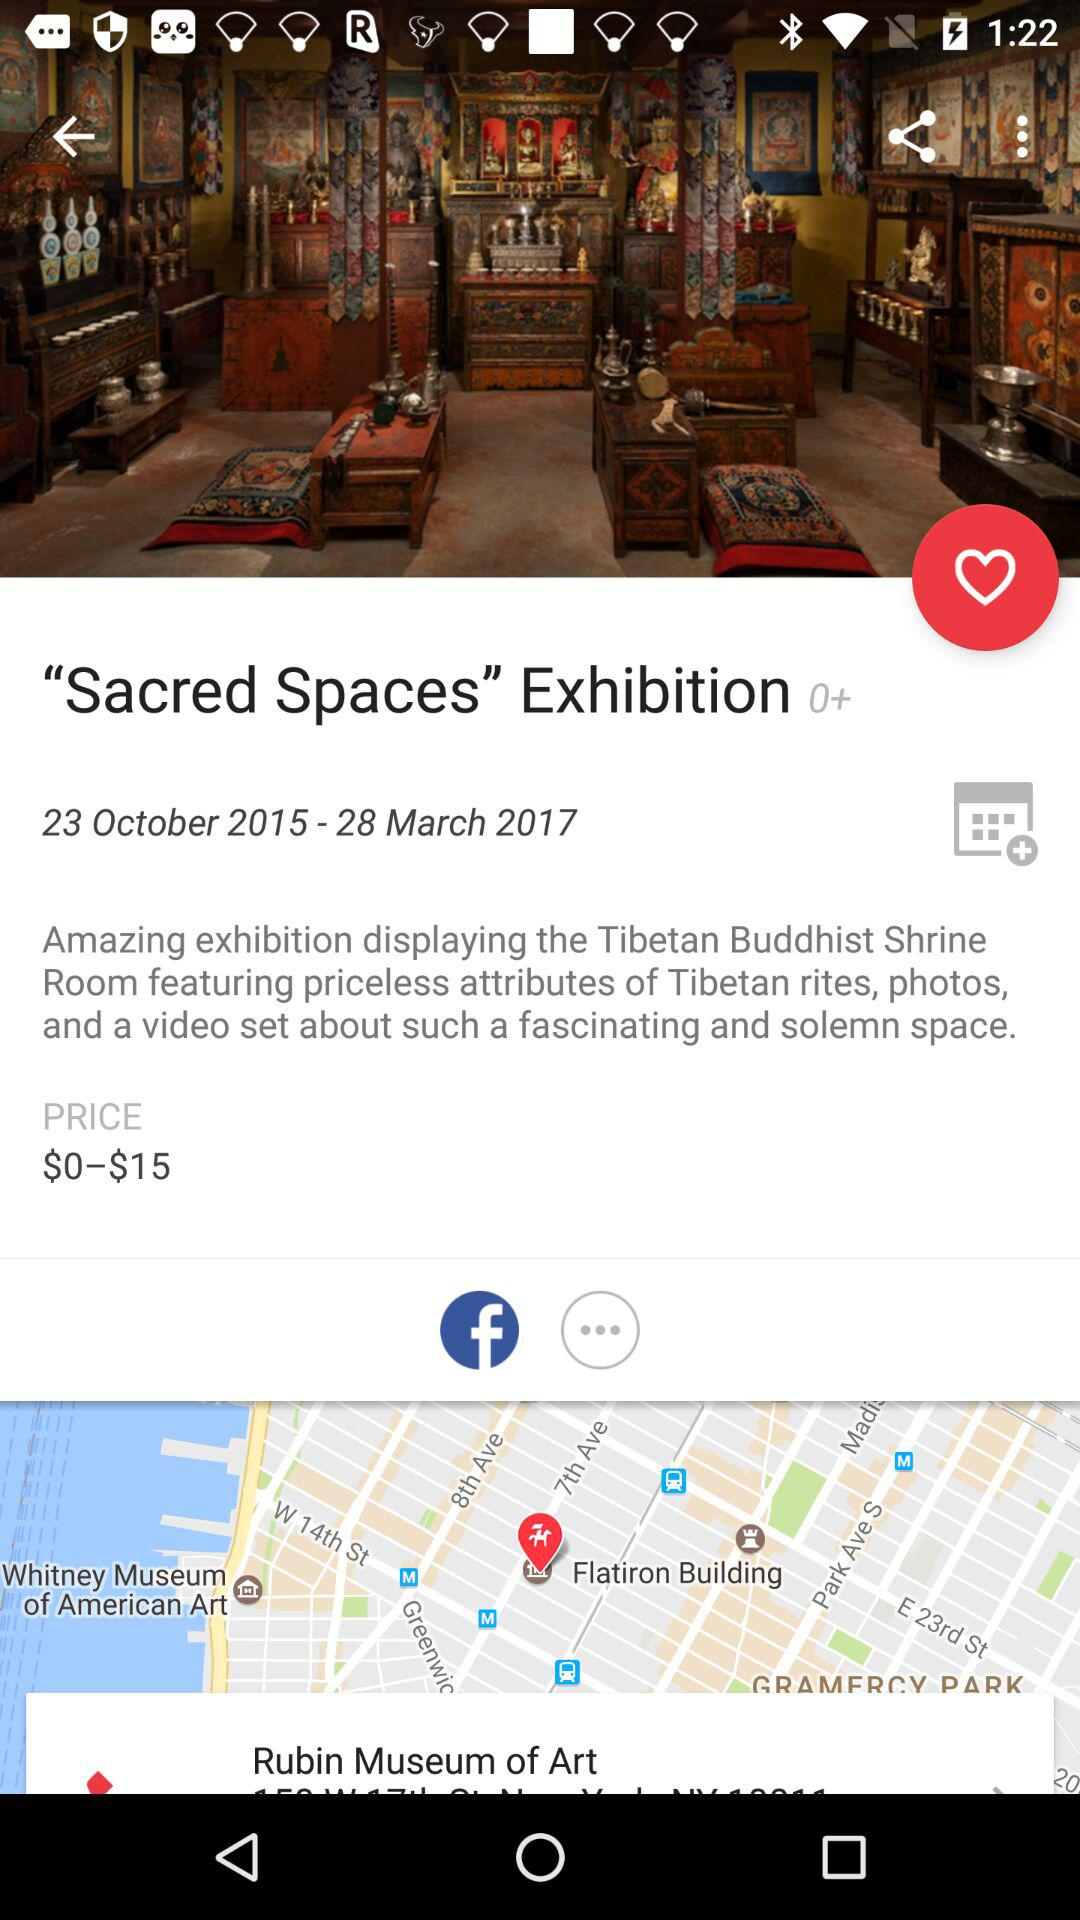What is the date of the "Sacred Spaces" exhibition? The date is October 23, 2015-March 28, 2017. 